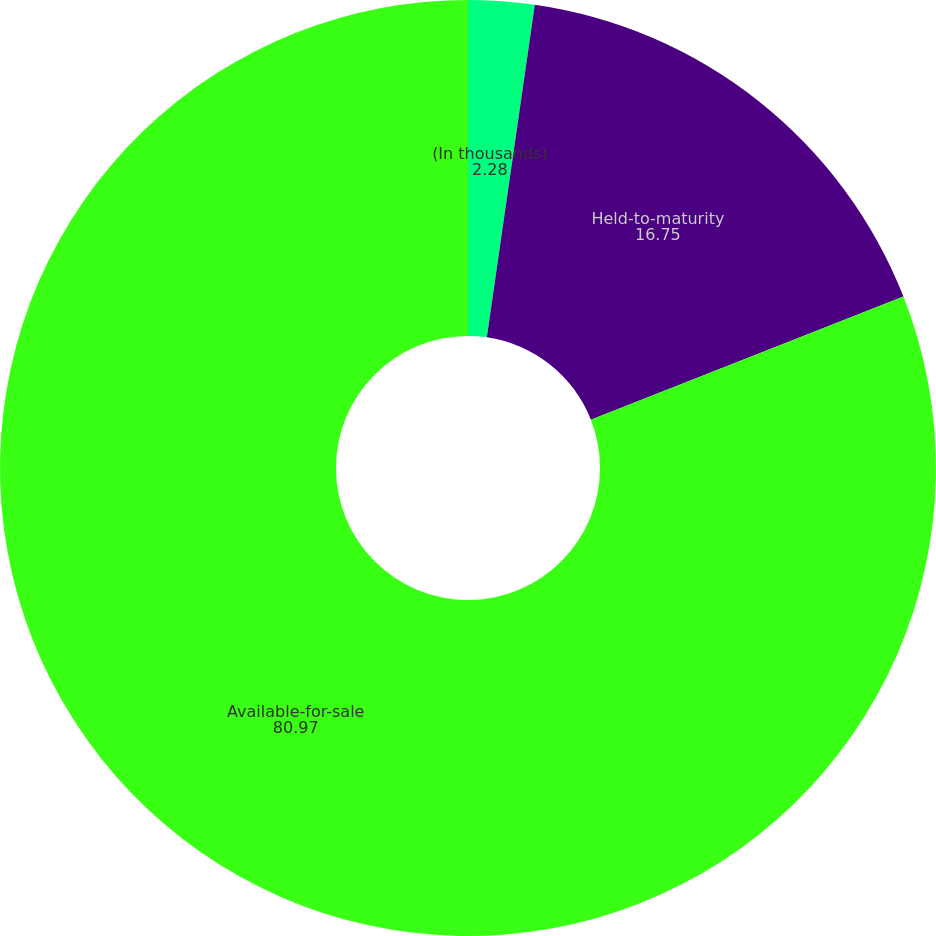<chart> <loc_0><loc_0><loc_500><loc_500><pie_chart><fcel>(In thousands)<fcel>Held-to-maturity<fcel>Available-for-sale<nl><fcel>2.28%<fcel>16.75%<fcel>80.97%<nl></chart> 